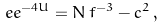<formula> <loc_0><loc_0><loc_500><loc_500>\ e e ^ { - 4 U } = N \, f ^ { - 3 } - c ^ { 2 } \, ,</formula> 